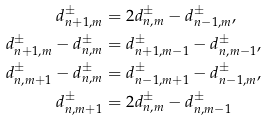<formula> <loc_0><loc_0><loc_500><loc_500>d _ { n + 1 , m } ^ { \pm } & = 2 d _ { n , m } ^ { \pm } - d _ { n - 1 , m } ^ { \pm } , \\ d _ { n + 1 , m } ^ { \pm } - d _ { n , m } ^ { \pm } & = d _ { n + 1 , m - 1 } ^ { \pm } - d _ { n , m - 1 } ^ { \pm } , \\ d _ { n , m + 1 } ^ { \pm } - d _ { n , m } ^ { \pm } & = d _ { n - 1 , m + 1 } ^ { \pm } - d _ { n - 1 , m } ^ { \pm } , \\ d _ { n , m + 1 } ^ { \pm } & = 2 d _ { n , m } ^ { \pm } - d _ { n , m - 1 } ^ { \pm }</formula> 